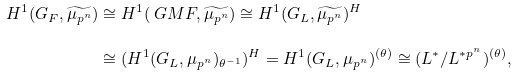<formula> <loc_0><loc_0><loc_500><loc_500>H ^ { 1 } ( G _ { F } , \widetilde { \mu _ { p ^ { n } } } ) & \cong H ^ { 1 } ( \ G M F , \widetilde { \mu _ { p ^ { n } } } ) \cong H ^ { 1 } ( G _ { L } , \widetilde { \mu _ { p ^ { n } } } ) ^ { H } \\ & \cong ( H ^ { 1 } ( G _ { L } , \mu _ { p ^ { n } } ) _ { \theta ^ { - 1 } } ) ^ { H } = H ^ { 1 } ( G _ { L } , \mu _ { p ^ { n } } ) ^ { ( \theta ) } \cong ( L ^ { * } / L ^ { * p ^ { n } } ) ^ { ( \theta ) } ,</formula> 